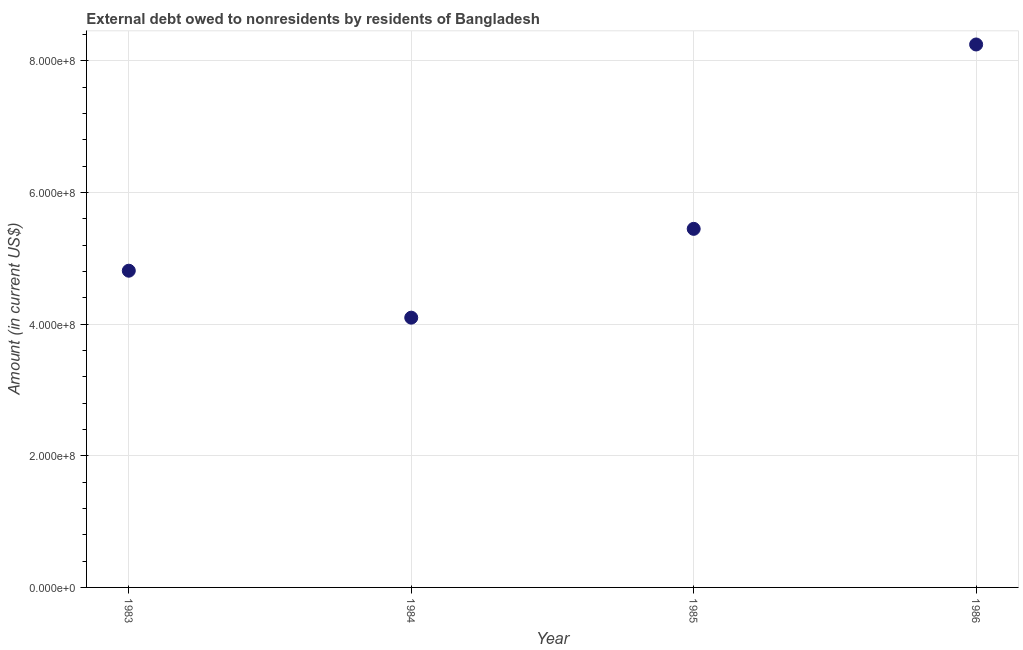What is the debt in 1986?
Ensure brevity in your answer.  8.25e+08. Across all years, what is the maximum debt?
Offer a terse response. 8.25e+08. Across all years, what is the minimum debt?
Your answer should be very brief. 4.10e+08. In which year was the debt minimum?
Offer a very short reply. 1984. What is the sum of the debt?
Your response must be concise. 2.26e+09. What is the difference between the debt in 1983 and 1984?
Keep it short and to the point. 7.13e+07. What is the average debt per year?
Ensure brevity in your answer.  5.65e+08. What is the median debt?
Offer a very short reply. 5.13e+08. In how many years, is the debt greater than 560000000 US$?
Provide a succinct answer. 1. What is the ratio of the debt in 1984 to that in 1986?
Your response must be concise. 0.5. Is the debt in 1983 less than that in 1984?
Provide a succinct answer. No. Is the difference between the debt in 1984 and 1985 greater than the difference between any two years?
Offer a very short reply. No. What is the difference between the highest and the second highest debt?
Your response must be concise. 2.80e+08. Is the sum of the debt in 1983 and 1985 greater than the maximum debt across all years?
Ensure brevity in your answer.  Yes. What is the difference between the highest and the lowest debt?
Your answer should be compact. 4.15e+08. How many dotlines are there?
Give a very brief answer. 1. How many years are there in the graph?
Provide a short and direct response. 4. What is the difference between two consecutive major ticks on the Y-axis?
Offer a very short reply. 2.00e+08. Does the graph contain any zero values?
Offer a very short reply. No. What is the title of the graph?
Offer a very short reply. External debt owed to nonresidents by residents of Bangladesh. What is the label or title of the X-axis?
Your answer should be compact. Year. What is the label or title of the Y-axis?
Your response must be concise. Amount (in current US$). What is the Amount (in current US$) in 1983?
Offer a terse response. 4.81e+08. What is the Amount (in current US$) in 1984?
Offer a very short reply. 4.10e+08. What is the Amount (in current US$) in 1985?
Your answer should be compact. 5.45e+08. What is the Amount (in current US$) in 1986?
Your response must be concise. 8.25e+08. What is the difference between the Amount (in current US$) in 1983 and 1984?
Your answer should be very brief. 7.13e+07. What is the difference between the Amount (in current US$) in 1983 and 1985?
Your answer should be very brief. -6.36e+07. What is the difference between the Amount (in current US$) in 1983 and 1986?
Your answer should be compact. -3.44e+08. What is the difference between the Amount (in current US$) in 1984 and 1985?
Make the answer very short. -1.35e+08. What is the difference between the Amount (in current US$) in 1984 and 1986?
Offer a very short reply. -4.15e+08. What is the difference between the Amount (in current US$) in 1985 and 1986?
Your response must be concise. -2.80e+08. What is the ratio of the Amount (in current US$) in 1983 to that in 1984?
Make the answer very short. 1.17. What is the ratio of the Amount (in current US$) in 1983 to that in 1985?
Keep it short and to the point. 0.88. What is the ratio of the Amount (in current US$) in 1983 to that in 1986?
Offer a very short reply. 0.58. What is the ratio of the Amount (in current US$) in 1984 to that in 1985?
Make the answer very short. 0.75. What is the ratio of the Amount (in current US$) in 1984 to that in 1986?
Offer a terse response. 0.5. What is the ratio of the Amount (in current US$) in 1985 to that in 1986?
Make the answer very short. 0.66. 